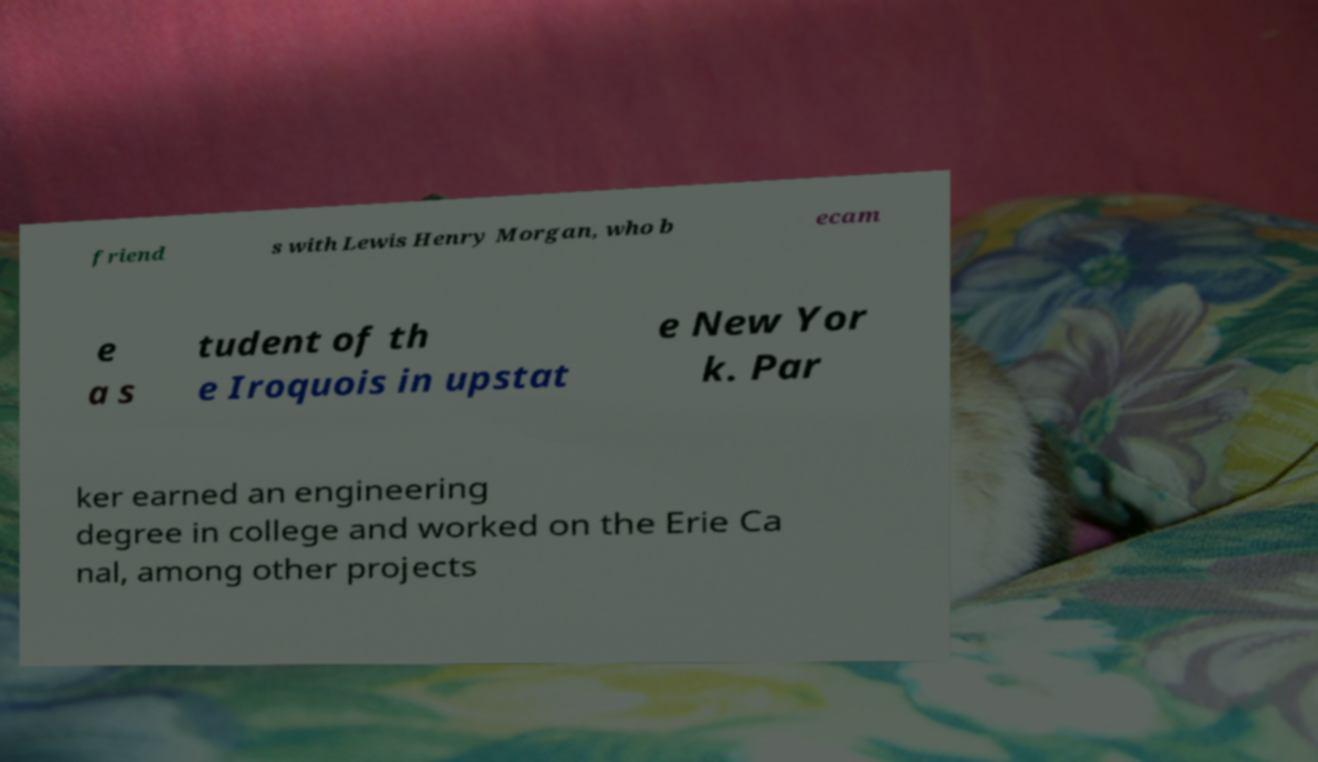What messages or text are displayed in this image? I need them in a readable, typed format. friend s with Lewis Henry Morgan, who b ecam e a s tudent of th e Iroquois in upstat e New Yor k. Par ker earned an engineering degree in college and worked on the Erie Ca nal, among other projects 